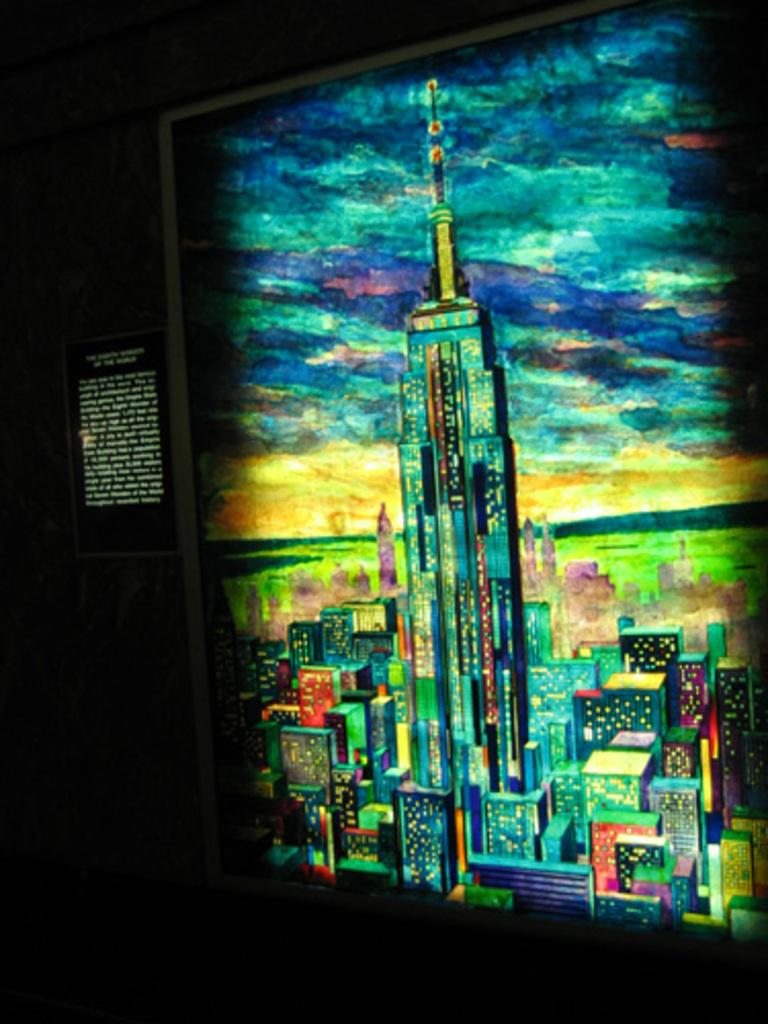What is the main subject of the painting in the image? The main subject of the painting in the image is buildings. What can be observed about the background of the image? The background of the image is dark. What type of orange is being used to support the buildings in the image? There is no orange present in the image, and the buildings are not being supported by any fruit. 